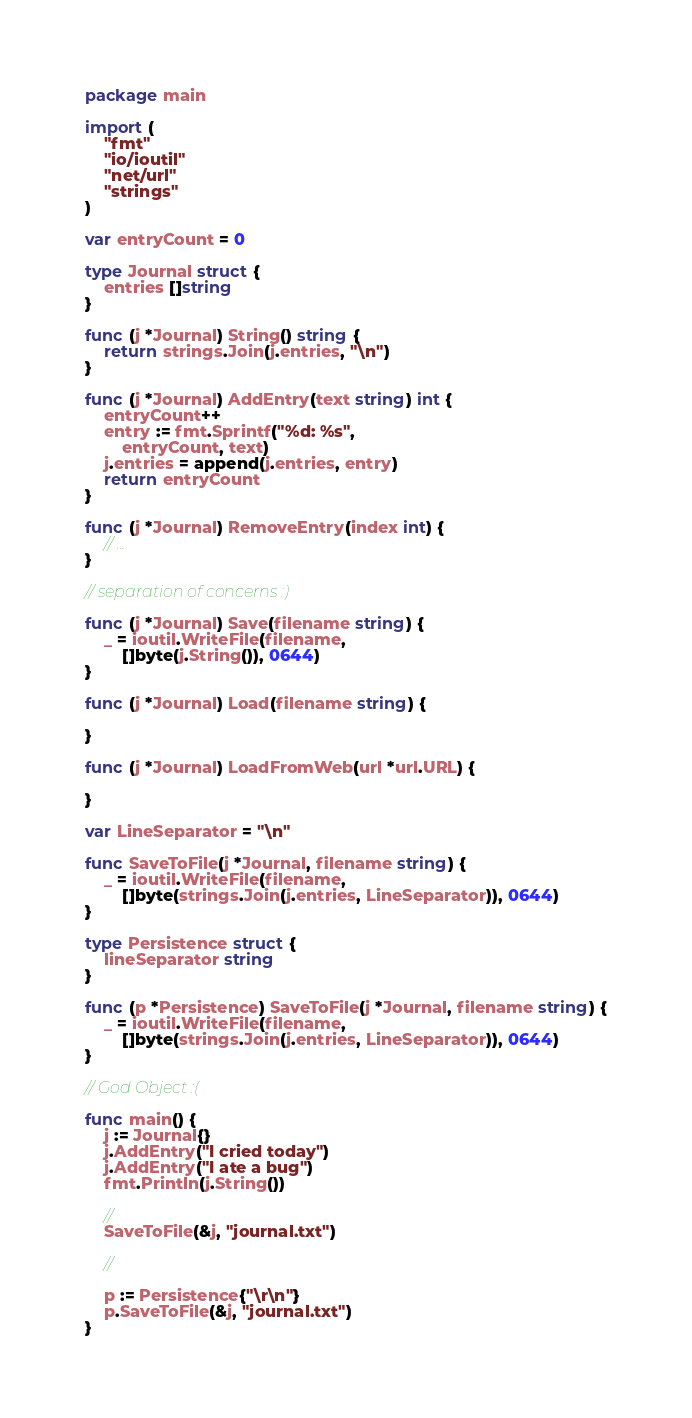Convert code to text. <code><loc_0><loc_0><loc_500><loc_500><_Go_>package main

import (
	"fmt"
	"io/ioutil"
	"net/url"
	"strings"
)

var entryCount = 0

type Journal struct {
	entries []string
}

func (j *Journal) String() string {
	return strings.Join(j.entries, "\n")
}

func (j *Journal) AddEntry(text string) int {
	entryCount++
	entry := fmt.Sprintf("%d: %s",
		entryCount, text)
	j.entries = append(j.entries, entry)
	return entryCount
}

func (j *Journal) RemoveEntry(index int) {
	// ...
}

// separation of concerns :)

func (j *Journal) Save(filename string) {
	_ = ioutil.WriteFile(filename,
		[]byte(j.String()), 0644)
}

func (j *Journal) Load(filename string) {

}

func (j *Journal) LoadFromWeb(url *url.URL) {

}

var LineSeparator = "\n"

func SaveToFile(j *Journal, filename string) {
	_ = ioutil.WriteFile(filename,
		[]byte(strings.Join(j.entries, LineSeparator)), 0644)
}

type Persistence struct {
	lineSeparator string
}

func (p *Persistence) SaveToFile(j *Journal, filename string) {
	_ = ioutil.WriteFile(filename,
		[]byte(strings.Join(j.entries, LineSeparator)), 0644)
}

// God Object :(

func main() {
	j := Journal{}
	j.AddEntry("I cried today")
	j.AddEntry("I ate a bug")
	fmt.Println(j.String())

	//
	SaveToFile(&j, "journal.txt")

	//

	p := Persistence{"\r\n"}
	p.SaveToFile(&j, "journal.txt")
}
</code> 